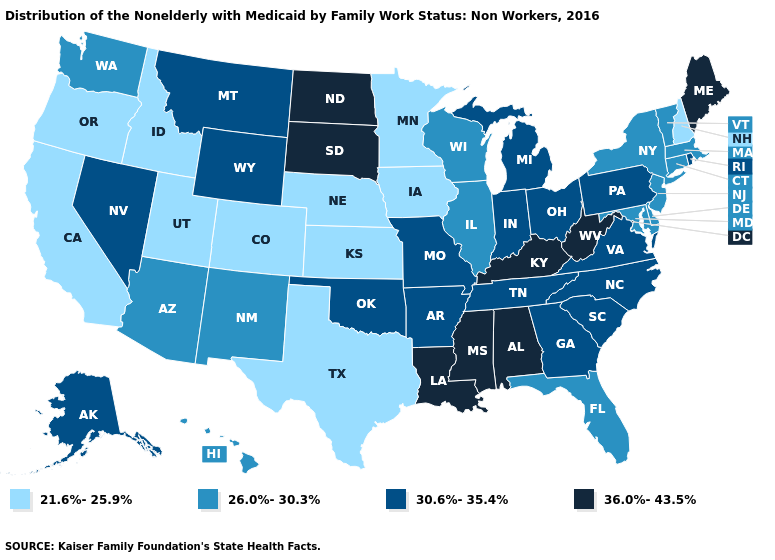What is the lowest value in states that border Wisconsin?
Short answer required. 21.6%-25.9%. What is the value of Mississippi?
Keep it brief. 36.0%-43.5%. What is the lowest value in the USA?
Be succinct. 21.6%-25.9%. What is the lowest value in the South?
Keep it brief. 21.6%-25.9%. What is the highest value in the West ?
Keep it brief. 30.6%-35.4%. Which states have the lowest value in the MidWest?
Keep it brief. Iowa, Kansas, Minnesota, Nebraska. Does the first symbol in the legend represent the smallest category?
Give a very brief answer. Yes. Among the states that border New York , does Pennsylvania have the lowest value?
Be succinct. No. Which states have the lowest value in the USA?
Quick response, please. California, Colorado, Idaho, Iowa, Kansas, Minnesota, Nebraska, New Hampshire, Oregon, Texas, Utah. Among the states that border Colorado , does Arizona have the lowest value?
Short answer required. No. Name the states that have a value in the range 36.0%-43.5%?
Short answer required. Alabama, Kentucky, Louisiana, Maine, Mississippi, North Dakota, South Dakota, West Virginia. Name the states that have a value in the range 21.6%-25.9%?
Write a very short answer. California, Colorado, Idaho, Iowa, Kansas, Minnesota, Nebraska, New Hampshire, Oregon, Texas, Utah. Does Louisiana have the highest value in the USA?
Keep it brief. Yes. Name the states that have a value in the range 26.0%-30.3%?
Be succinct. Arizona, Connecticut, Delaware, Florida, Hawaii, Illinois, Maryland, Massachusetts, New Jersey, New Mexico, New York, Vermont, Washington, Wisconsin. What is the value of South Dakota?
Short answer required. 36.0%-43.5%. 